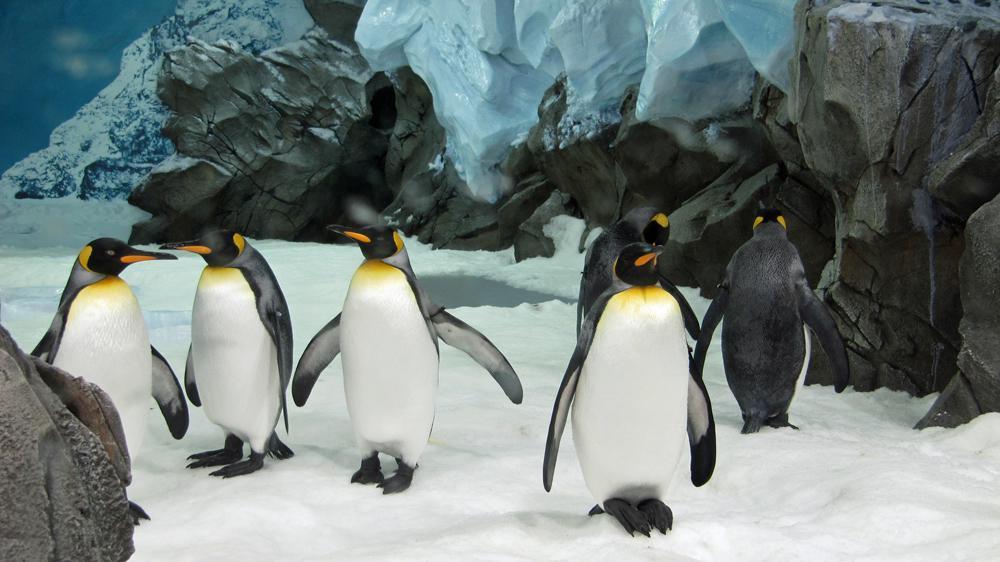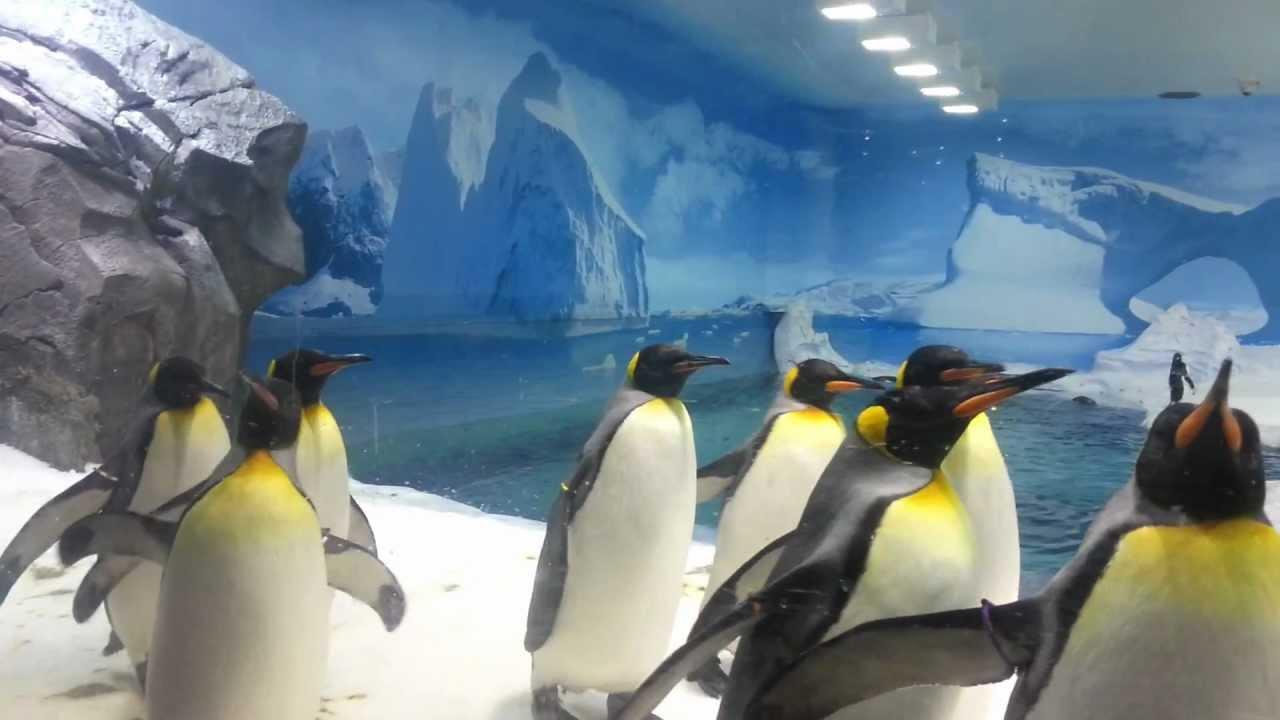The first image is the image on the left, the second image is the image on the right. Considering the images on both sides, is "Both photos in the pair have adult penguins and young penguins." valid? Answer yes or no. No. The first image is the image on the left, the second image is the image on the right. Analyze the images presented: Is the assertion "We can see exactly two baby penguins." valid? Answer yes or no. No. 